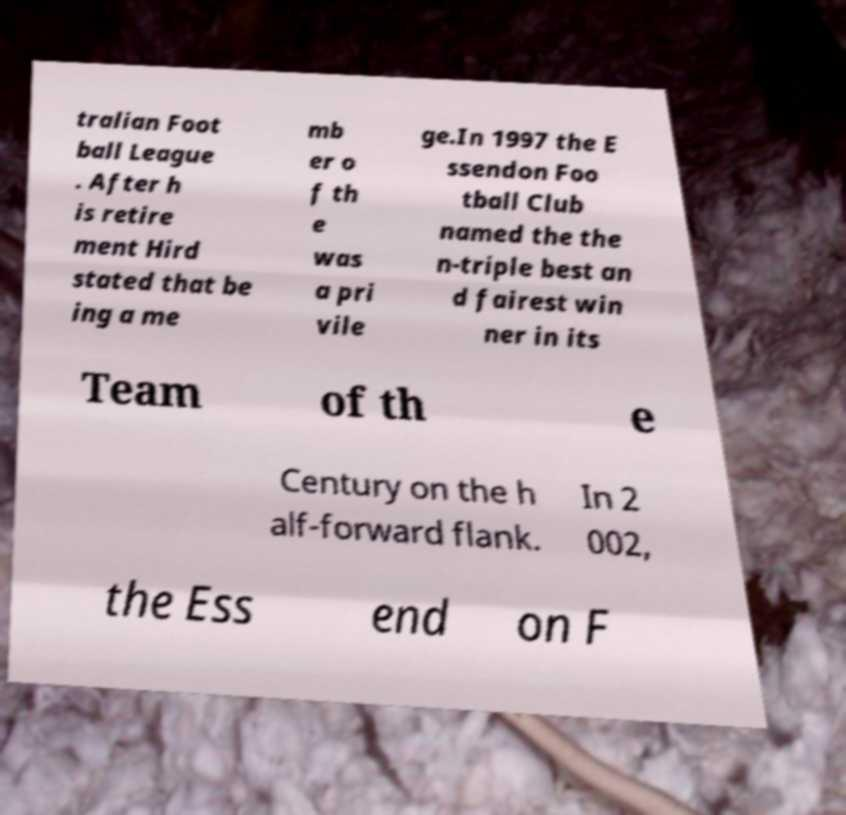I need the written content from this picture converted into text. Can you do that? tralian Foot ball League . After h is retire ment Hird stated that be ing a me mb er o f th e was a pri vile ge.In 1997 the E ssendon Foo tball Club named the the n-triple best an d fairest win ner in its Team of th e Century on the h alf-forward flank. In 2 002, the Ess end on F 